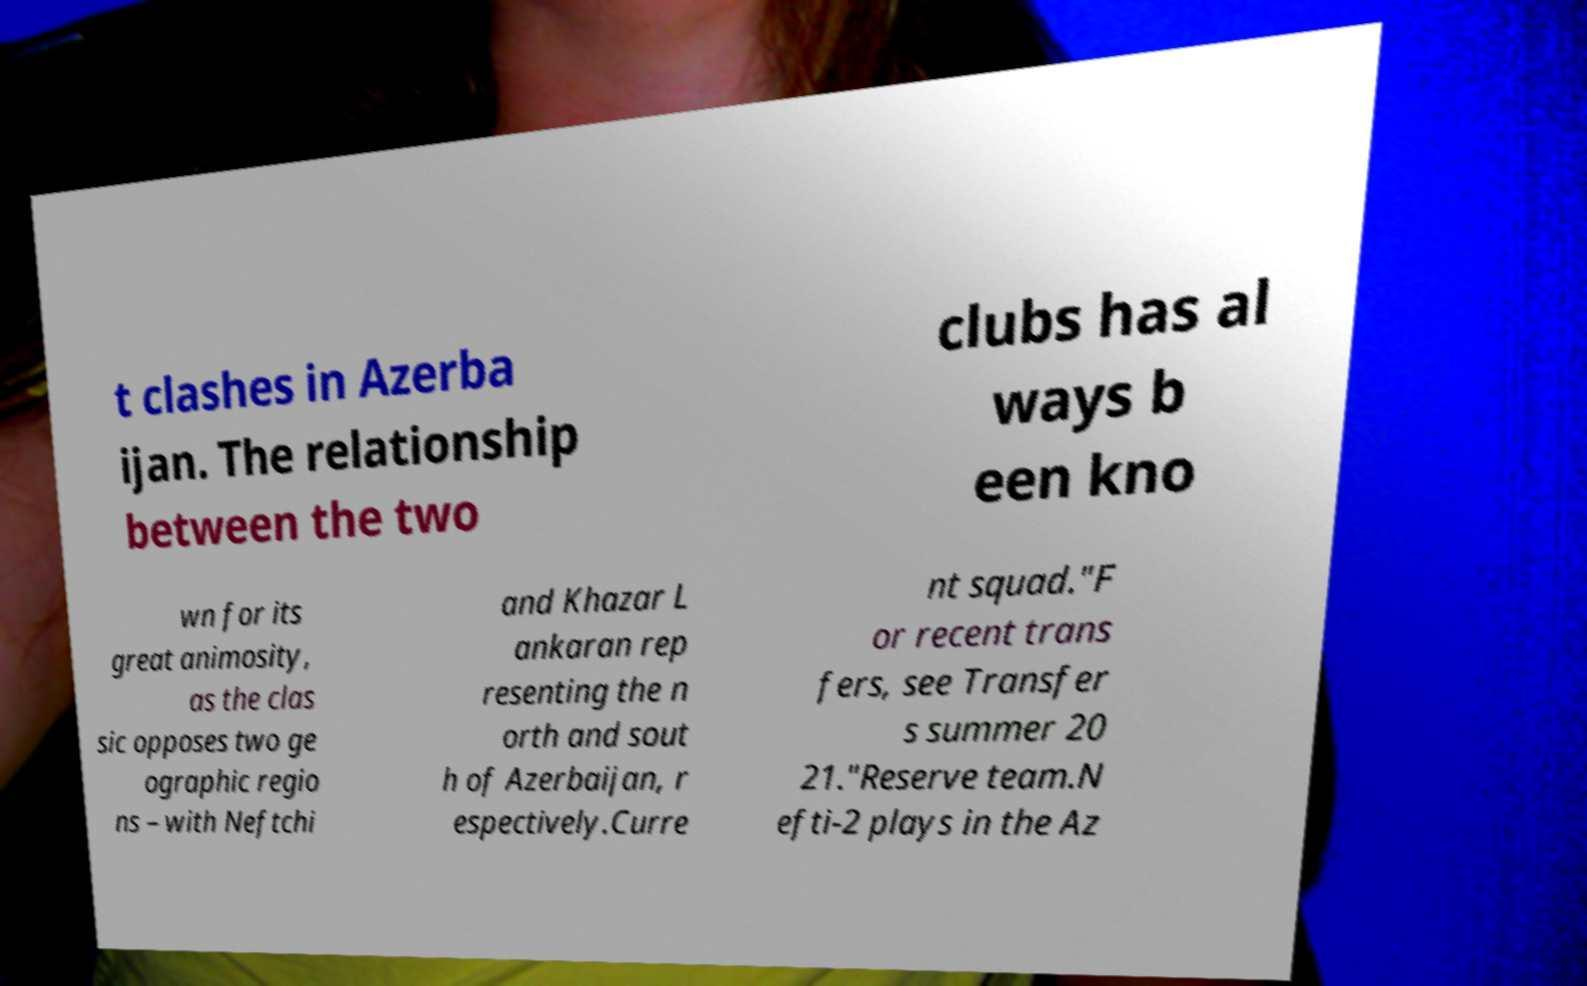Can you read and provide the text displayed in the image?This photo seems to have some interesting text. Can you extract and type it out for me? t clashes in Azerba ijan. The relationship between the two clubs has al ways b een kno wn for its great animosity, as the clas sic opposes two ge ographic regio ns – with Neftchi and Khazar L ankaran rep resenting the n orth and sout h of Azerbaijan, r espectively.Curre nt squad."F or recent trans fers, see Transfer s summer 20 21."Reserve team.N efti-2 plays in the Az 